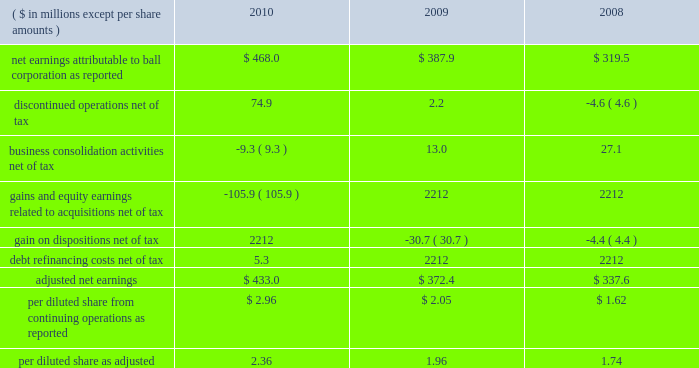Page 26 of 100 our calculation of adjusted net earnings is summarized below: .
Debt facilities and refinancing interest-bearing debt at december 31 , 2010 , increased $ 216.1 million to $ 2.8 billion from $ 2.6 billion at december 31 , 2009 .
In december 2010 , ball replaced its senior credit facilities due october 2011 with new senior credit facilities due december 2015 .
The senior credit facilities bear interest at variable rates and include a $ 200 million term a loan denominated in u.s .
Dollars , a a351 million term b loan denominated in british sterling and a 20ac100 million term c loan denominated in euros .
The facilities also include ( 1 ) a multi-currency , long-term revolving credit facility that provides the company with up to approximately $ 850 million and ( 2 ) a french multi-currency revolving facility that provides the company with up to $ 150 million .
The revolving credit facilities expire in december 2015 .
In november 2010 , ball issued $ 500 million of new 5.75 percent senior notes due in may 2021 .
The net proceeds from this offering were used to repay the borrowings under our term d loan facility and for general corporate purposes .
In march 2010 , ball issued $ 500 million of new 6.75 percent senior notes due in september 2020 .
On that same date , the company issued a notice of redemption to call $ 509 million in 6.875 percent senior notes due december 2012 at a redemption price of 101.146 percent of the outstanding principal amount plus accrued interest .
The redemption of the bonds occurred on april 21 , 2010 , and resulted in a charge of $ 8.1 million for the call premium and the write off of unamortized financing costs and unamortized premiums .
The charge is included in the 2010 statement of earnings as a component of interest expense .
At december 31 , 2010 , approximately $ 976 million was available under the company 2019s committed multi-currency revolving credit facilities .
The company 2019s prc operations also had approximately $ 20 million available under a committed credit facility of approximately $ 52 million .
In addition to the long-term committed credit facilities , the company had $ 372 million of short-term uncommitted credit facilities available at the end of 2010 , of which $ 76.2 million was outstanding and due on demand , as well as approximately $ 175 million of available borrowings under its accounts receivable securitization program .
In october 2010 , the company renewed its receivables sales agreement for a period of one year .
The size of the new program will vary between a maximum of $ 125 million for settlement dates in january through april and a maximum of $ 175 million for settlement dates in the remaining months .
Given our free cash flow projections and unused credit facilities that are available until december 2015 , our liquidity is strong and is expected to meet our ongoing operating cash flow and debt service requirements .
While the recent financial and economic conditions have raised concerns about credit risk with counterparties to derivative transactions , the company mitigates its exposure by spreading the risk among various counterparties and limiting exposure to any one party .
We also monitor the credit ratings of our suppliers , customers , lenders and counterparties on a regular basis .
We were in compliance with all loan agreements at december 31 , 2010 , and all prior years presented , and have met all debt payment obligations .
The u.s .
Note agreements , bank credit agreement and industrial development revenue bond agreements contain certain restrictions relating to dividends , investments , financial ratios , guarantees and the incurrence of additional indebtedness .
Additional details about our debt and receivables sales agreements are available in notes 12 and 6 , respectively , accompanying the consolidated financial statements within item 8 of this report. .
What was the percentage change in per diluted share earnings as adjusted from 2008 to 2009? 
Computations: ((1.96 - 1.74) / 1.74)
Answer: 0.12644. 